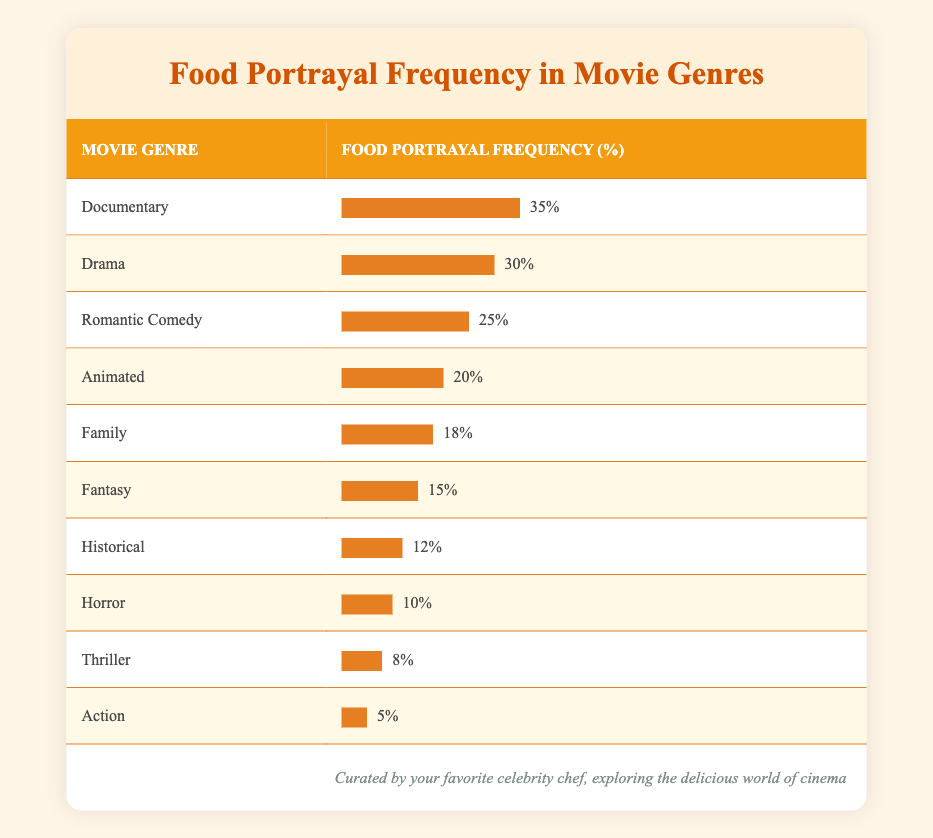What is the food portrayal frequency for Romantic Comedy? The table shows that the Food Portrayal Frequency for Romantic Comedy is listed as 25%.
Answer: 25% Which movie genre has the highest food portrayal frequency? According to the table, the Documentary genre has the highest frequency at 35%.
Answer: 35% Is the food portrayal frequency for Action higher than that for Thriller? The table shows that Action has a frequency of 5%, while Thriller has 8%. Thus, Action is not higher than Thriller.
Answer: No What is the sum of the food portrayal frequencies for Drama, Family, and Animated genres? The food portrayal frequencies are 30% (Drama) + 18% (Family) + 20% (Animated) = 68%.
Answer: 68% Which genre has a food portrayal frequency that is lower than 15%? The genres listed with lower frequencies than 15% are Horror (10%) and Thriller (8%).
Answer: Horror and Thriller What is the average food portrayal frequency across all movie genres listed? To find the average, sum all frequencies: 35 + 30 + 25 + 20 + 18 + 15 + 12 + 10 + 8 + 5 =  278; There are 10 genres, so the average is 278/10 = 27.8%.
Answer: 27.8% Is there a genre with exactly 12% food portrayal frequency? The Historical genre has a food portrayal frequency of 12%, confirming the statement as true.
Answer: Yes Which two genres have food portrayal frequencies that can be averaged to result in exactly 20%? Combining the frequencies of Fantasy (15%) and Family (18%), we find that their average is (15 + 18)/2 = 16.5%, and thus, they cannot average to 20%. No pair qualifies.
Answer: No What percentage difference is there between the food portrayal frequency of Drama and Horror? The frequency difference is 30% (Drama) - 10% (Horror) = 20%, so the percentage difference is 20%.
Answer: 20% 